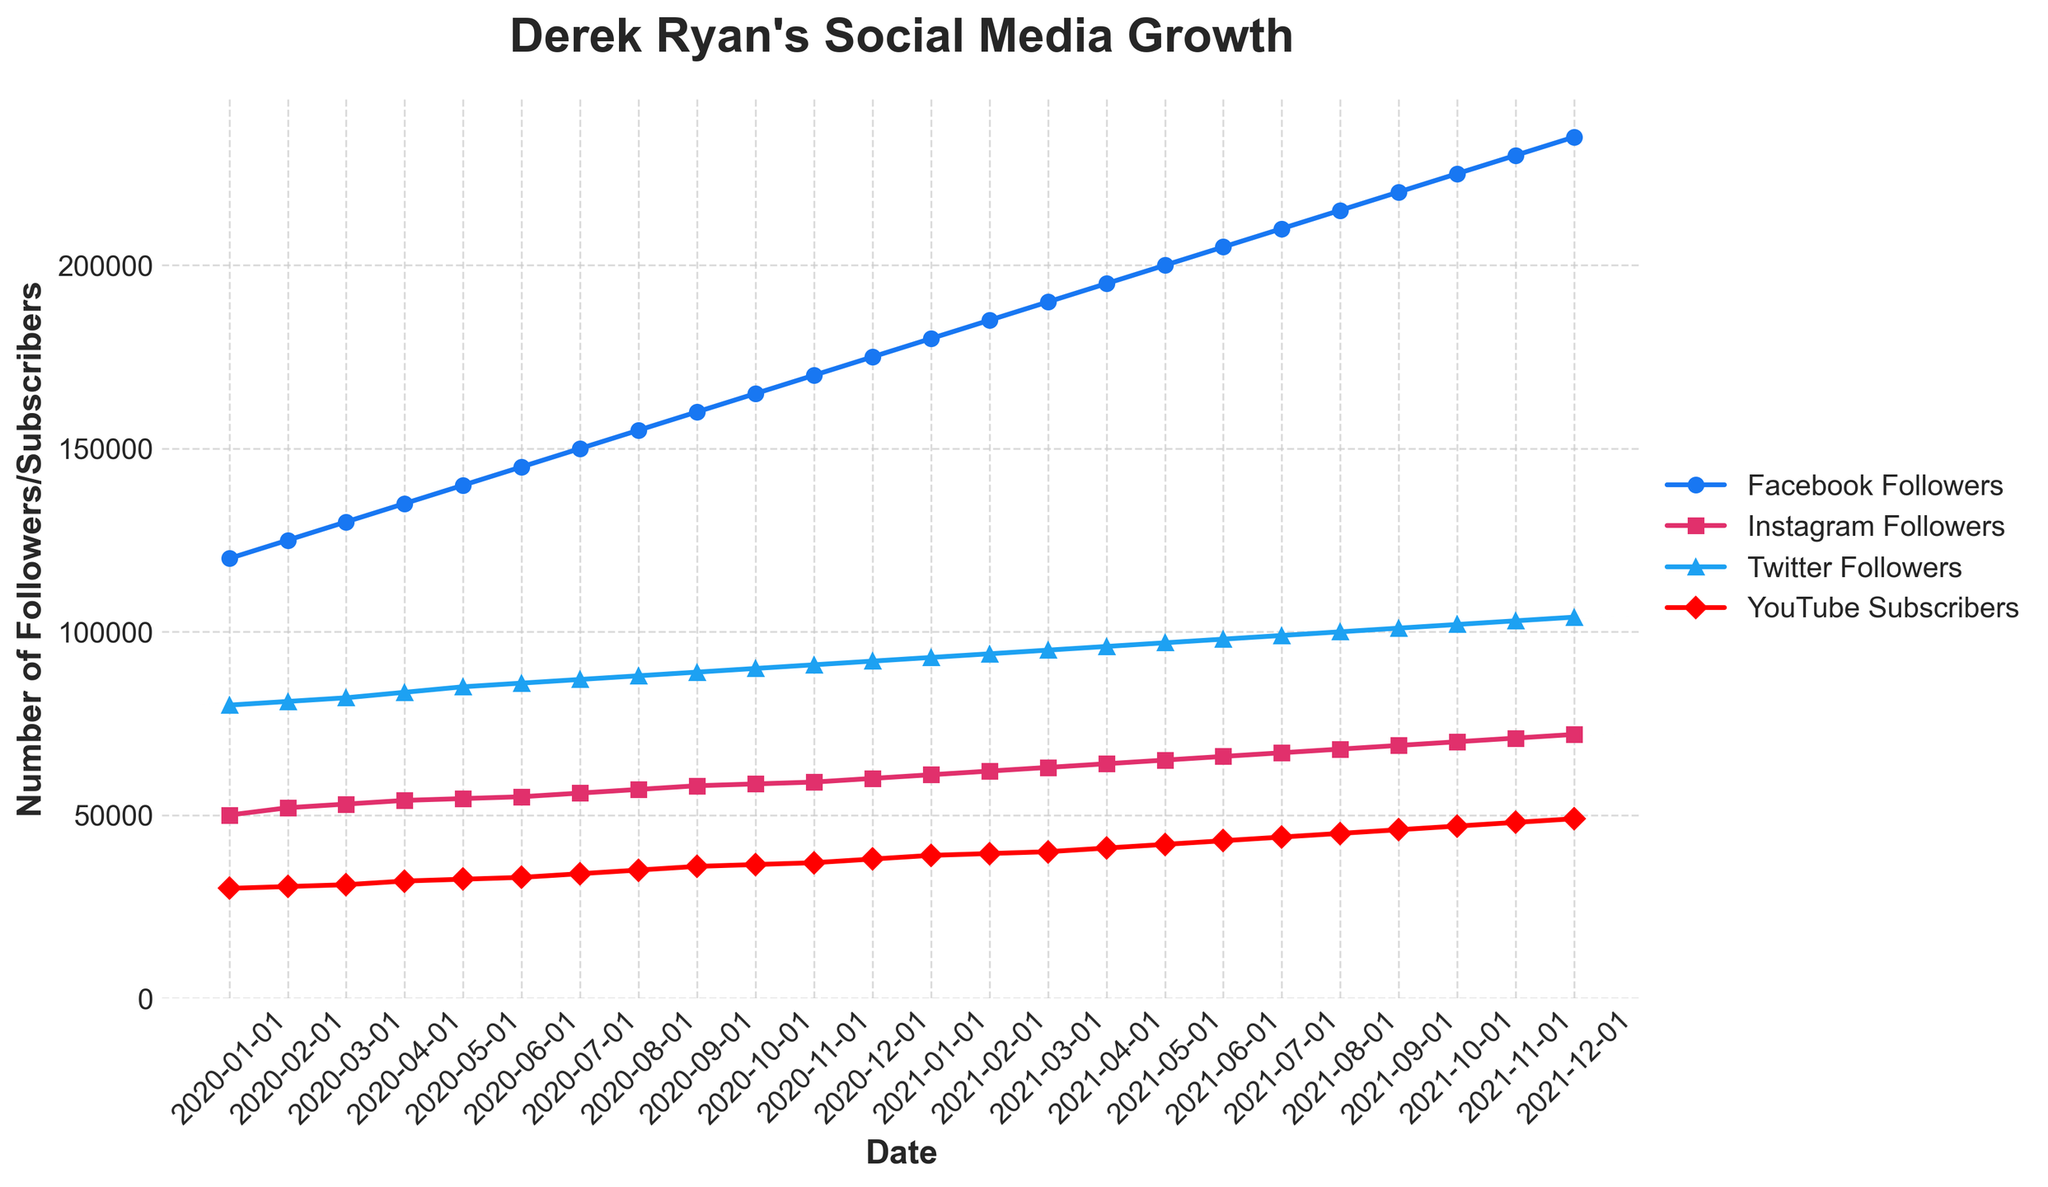what is the title of the plot? The title of the plot is written at the top of the figure. By looking at the top, it clearly states "Derek Ryan's Social Media Growth".
Answer: Derek Ryan's Social Media Growth what is the time span covered in the plot? By observing the 'Date' axis at the bottom, we can see the plot ranges from January 2020 to December 2021.
Answer: January 2020 to December 2021 which platform has the highest number of followers at the end of the period? At the end of the period (December 2021), the 'Facebook Followers' line is the highest, indicating over 230,000 followers.
Answer: Facebook Followers What was the total increase in Instagram Followers during 2020? The number of Instagram Followers in January 2020 was 50,000. In December 2020, it was 60,000. The difference is 60,000 - 50,000 = 10,000.
Answer: 10,000 Which platform saw the least number of followers in December 2021? By comparing the lines on the figure for December 2021, we can see the 'YouTube Subscribers' line is the lowest, indicating fewer than 50,000 subscribers.
Answer: YouTube Subscribers What was the average monthly increase in Twitter Followers during 2021? The number of Twitter Followers in January 2021 was 93,000. In December 2021, it was 104,000. So the total increase was 104,000 - 93,000 = 11,000. There are 12 months in a year, so the average monthly increase is 11,000 / 12 ≈ 917.
Answer: 917 How did the number of YouTube Subscribers change from July 2020 to July 2021? In July 2020, YouTube Subscribers were 34,000. In July 2021, it was 44,000. The change is 44,000 - 34,000 = 10,000.
Answer: Increased by 10,000 Which month showed the largest single-month increase in Facebook Followers? By closely examining the slopes of the 'Facebook Followers' line, the steepest increase appears between November 2021 and December 2021.
Answer: November 2021 to December 2021 Did any platform experience a decrease in followers at any point? All the lines in the plot show a consistent upward trend, indicating no decreases in followers for any platform.
Answer: No How many platforms crossed the 100,000 follower mark by the end of the period? By examining the points at the end of December 2021, we see only 'Facebook Followers' and 'Twitter Followers' are above 100,000.
Answer: 2 